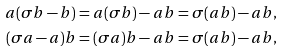Convert formula to latex. <formula><loc_0><loc_0><loc_500><loc_500>a ( \sigma b - b ) & = a ( \sigma b ) - a b = \sigma ( a b ) - a b , \\ ( \sigma a - a ) b & = ( \sigma a ) b - a b = \sigma ( a b ) - a b ,</formula> 